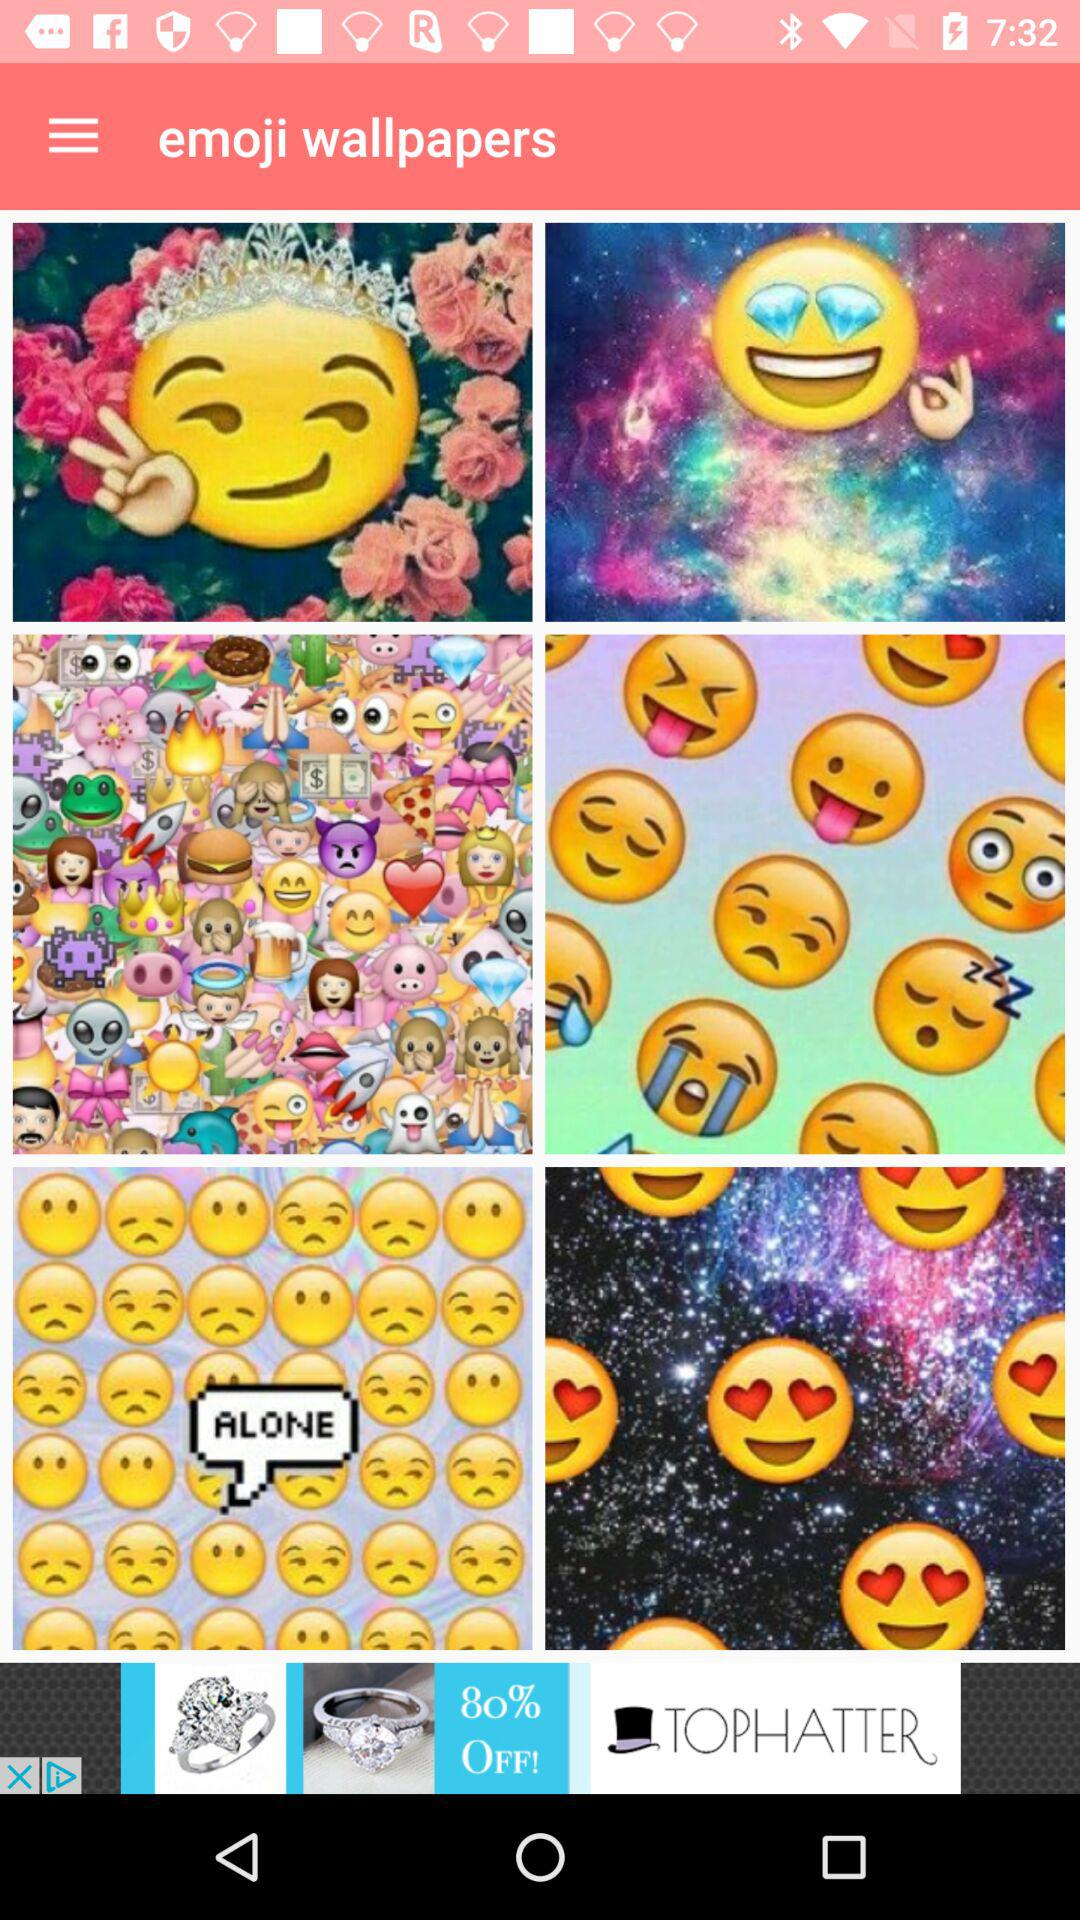What is the name of the application? The name of the application is "emoji wallpapers". 